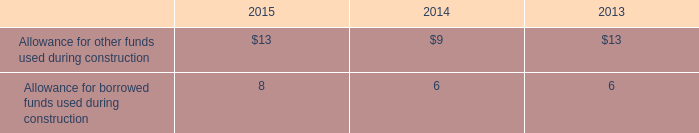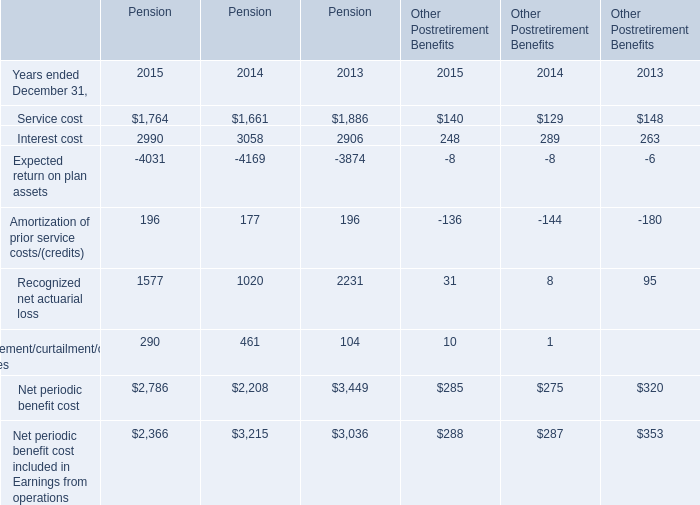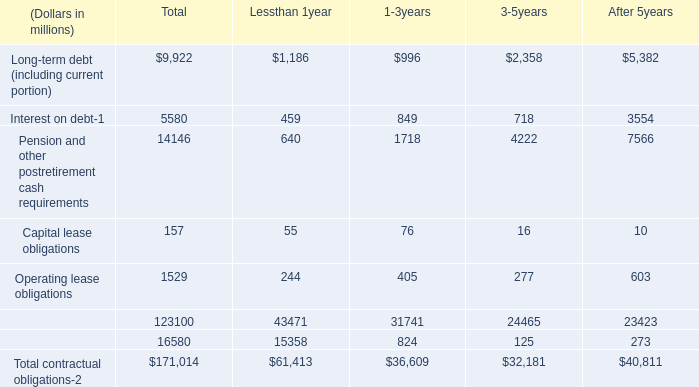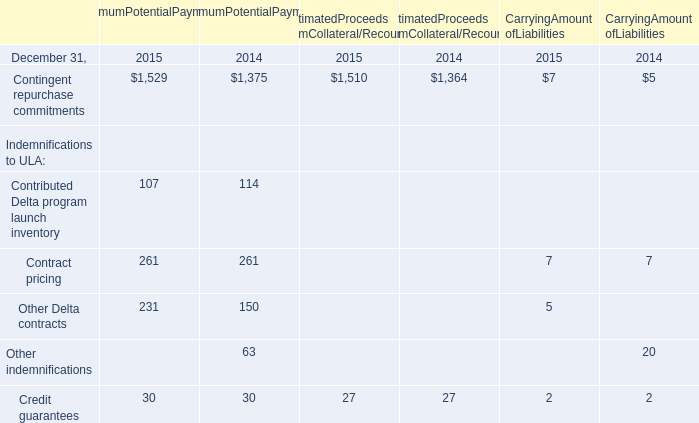What's the average of Contingent repurchase commitments of MaximumPotentialPayments 2014, and Service cost of Pension 2013 ? 
Computations: ((1375.0 + 1886.0) / 2)
Answer: 1630.5. 